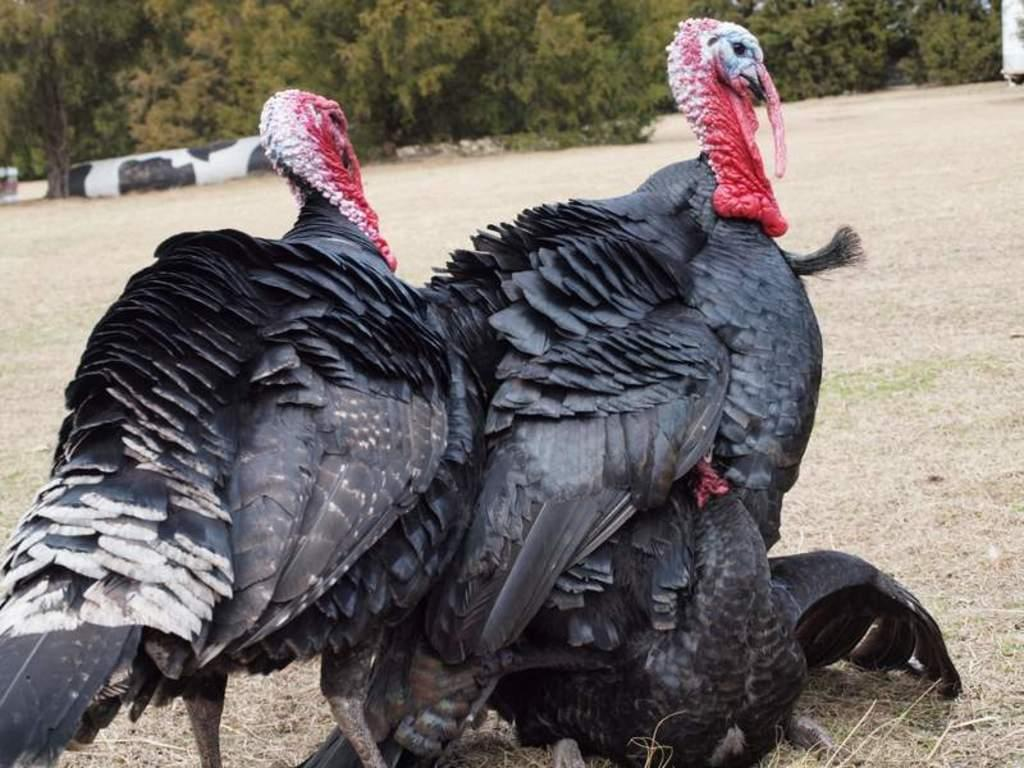What type of animals can be seen in the image? There are birds in the image. What color are the birds? The birds are black in color. Where are the birds located in the image? The birds are standing on the ground. What can be seen in the background of the image? There are trees visible at the top of the image. How far away is the rail from the birds in the image? There is no rail present in the image, so it is not possible to determine the distance between the birds and a rail. 